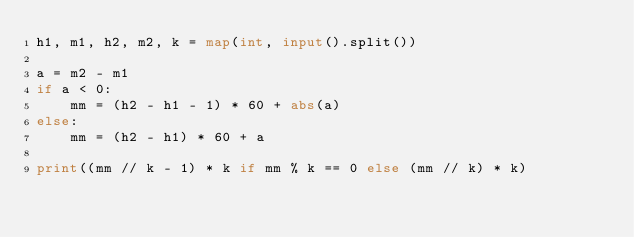Convert code to text. <code><loc_0><loc_0><loc_500><loc_500><_Python_>h1, m1, h2, m2, k = map(int, input().split())

a = m2 - m1
if a < 0:
    mm = (h2 - h1 - 1) * 60 + abs(a)
else:
    mm = (h2 - h1) * 60 + a

print((mm // k - 1) * k if mm % k == 0 else (mm // k) * k)</code> 